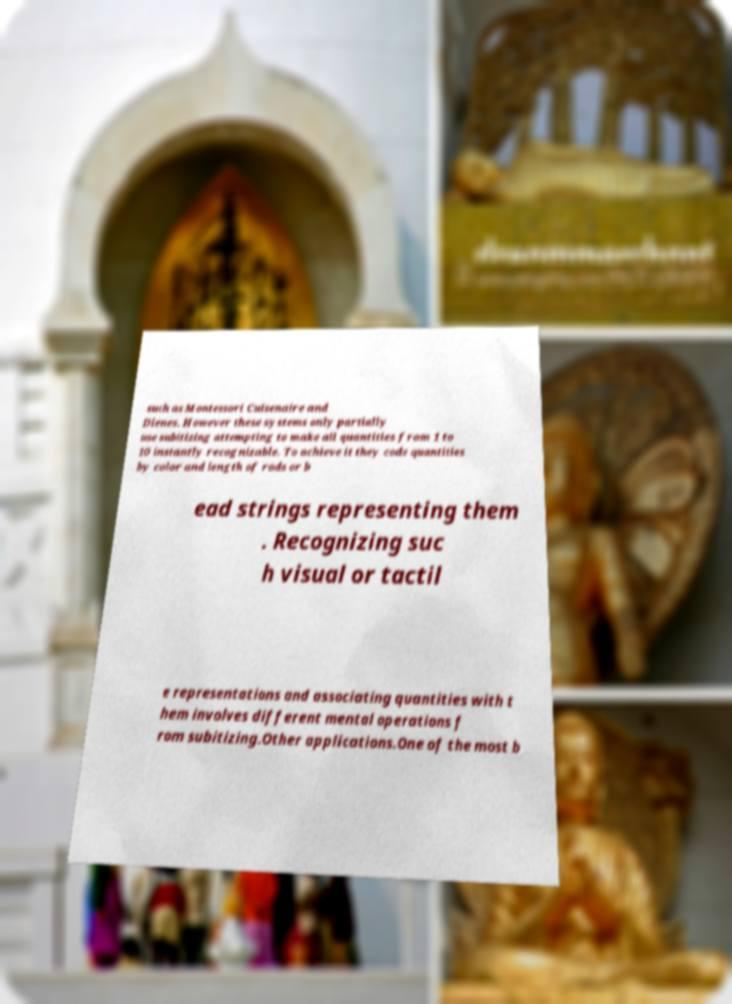Please read and relay the text visible in this image. What does it say? such as Montessori Cuisenaire and Dienes. However these systems only partially use subitizing attempting to make all quantities from 1 to 10 instantly recognizable. To achieve it they code quantities by color and length of rods or b ead strings representing them . Recognizing suc h visual or tactil e representations and associating quantities with t hem involves different mental operations f rom subitizing.Other applications.One of the most b 